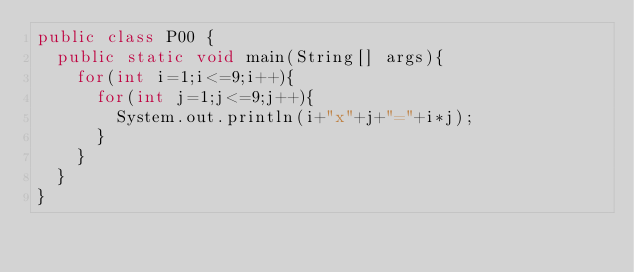<code> <loc_0><loc_0><loc_500><loc_500><_Java_>public class P00 {
	public static void main(String[] args){
		for(int i=1;i<=9;i++){
			for(int j=1;j<=9;j++){
				System.out.println(i+"x"+j+"="+i*j);
			}
		}
	}
}</code> 